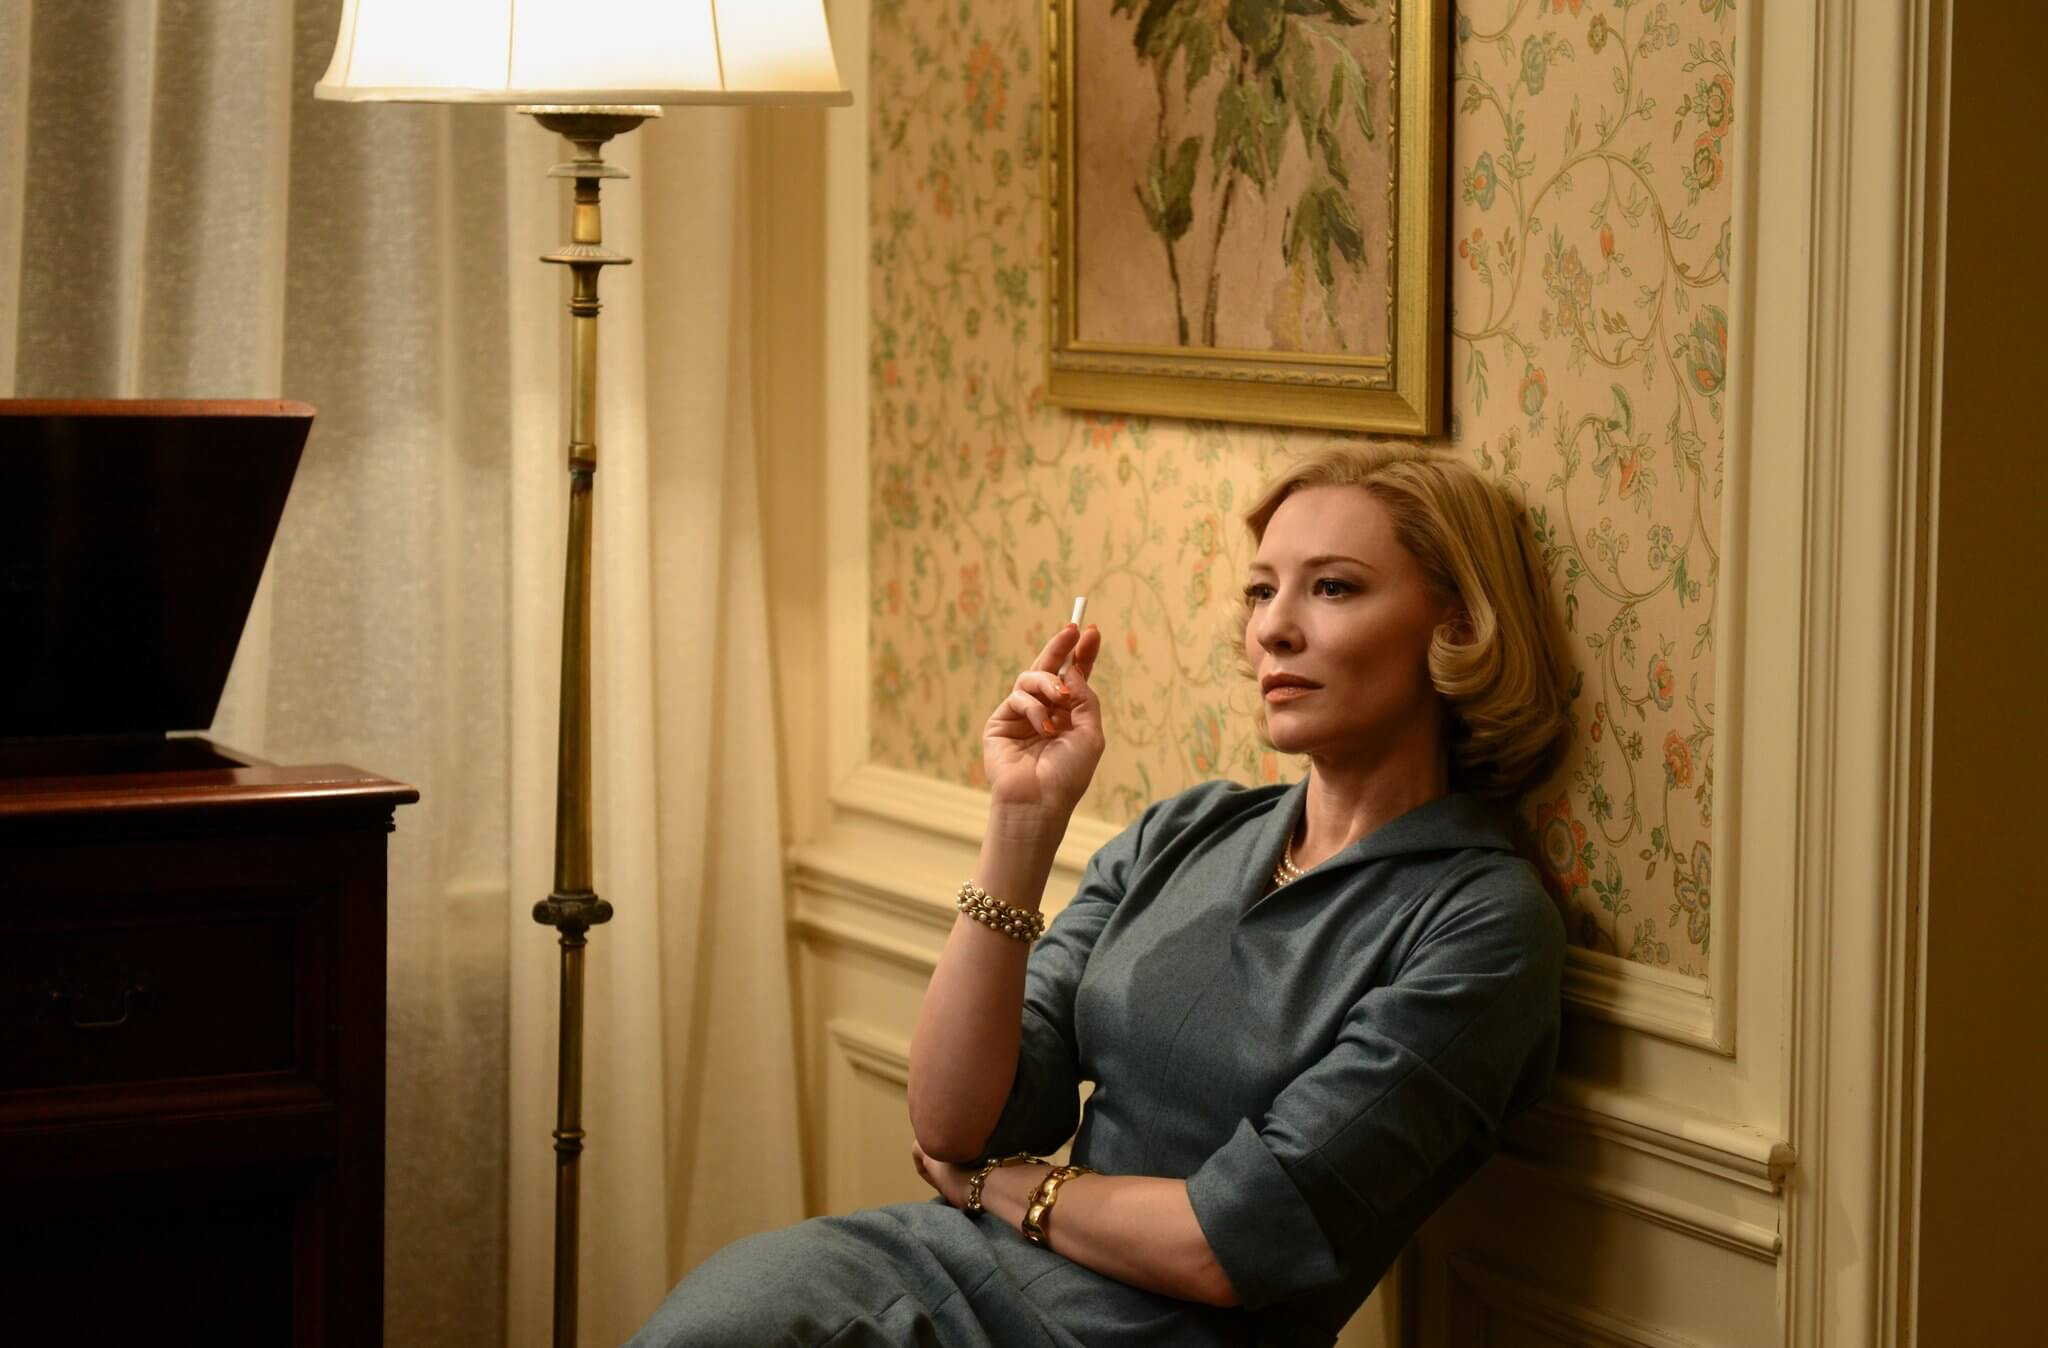Create a dialogue where the character speaks to the painting on the wall. Character: (lighting a cigarette and gazing at the painting) 'You’ve seen it all, haven’t you? The ups and downs, the laughter, and the tears. Whatever happened to those carefree days when everything seemed possible?'

Painting: (imaginium response) 'Time has its way with all things, dear. But within you, every moment still lives on, waiting to be rediscovered.'

Character: 'I wonder if I’ve lived up to the promises I once made to myself. Can one ever truly hold on to their dreams?'

Painting: 'Dreams have a way of evolving, but their essence remains within you. Embrace the journey, not just the destination, and you’ll find peace.'

Character: (smiling wistfully) 'You always know just what to say. Here’s to countless more reflections, old friend.' Compose a letter that the character might write in this moment. Dear [Recipient],

As I sit here, enveloped by the quiet comfort of this room, I find myself drawn into a web of memories and thoughts. The floral wallpaper, the faint yet steady glow of the lamp, and the lingering scent of smoke from my cigarette all conspire to create a reflective moment. It’s in these solitary instances that the mind wanders to places both near and distant, intertwined with the echoes of the past.

Life, it seems, is a continuous journey of fleeting moments, each leaving its indelible mark upon our souls. I’ve come to realize that while we often yearn for grand accomplishments, it’s the small, intimate experiences that shape us the most. They are the threads that weave the intricate tapestry of our existence.

I hope to rekindle the warmth and depth of our connection, to share more of these contemplative moments, whether in spirit or through written words. Let us cherish the simplicity and beauty found in the ordinary, for it is there that the true essence of life resides.

With heartfelt remembrance,
[Character] 